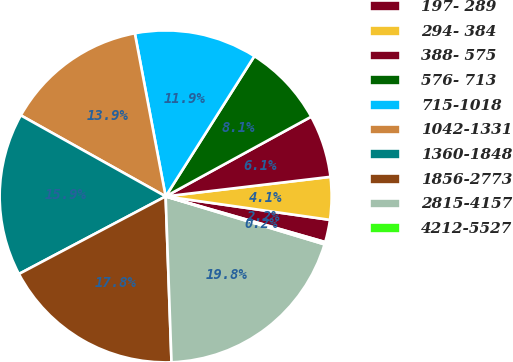Convert chart. <chart><loc_0><loc_0><loc_500><loc_500><pie_chart><fcel>197- 289<fcel>294- 384<fcel>388- 575<fcel>576- 713<fcel>715-1018<fcel>1042-1331<fcel>1360-1848<fcel>1856-2773<fcel>2815-4157<fcel>4212-5527<nl><fcel>2.18%<fcel>4.14%<fcel>6.09%<fcel>8.05%<fcel>11.95%<fcel>13.91%<fcel>15.86%<fcel>17.82%<fcel>19.77%<fcel>0.23%<nl></chart> 